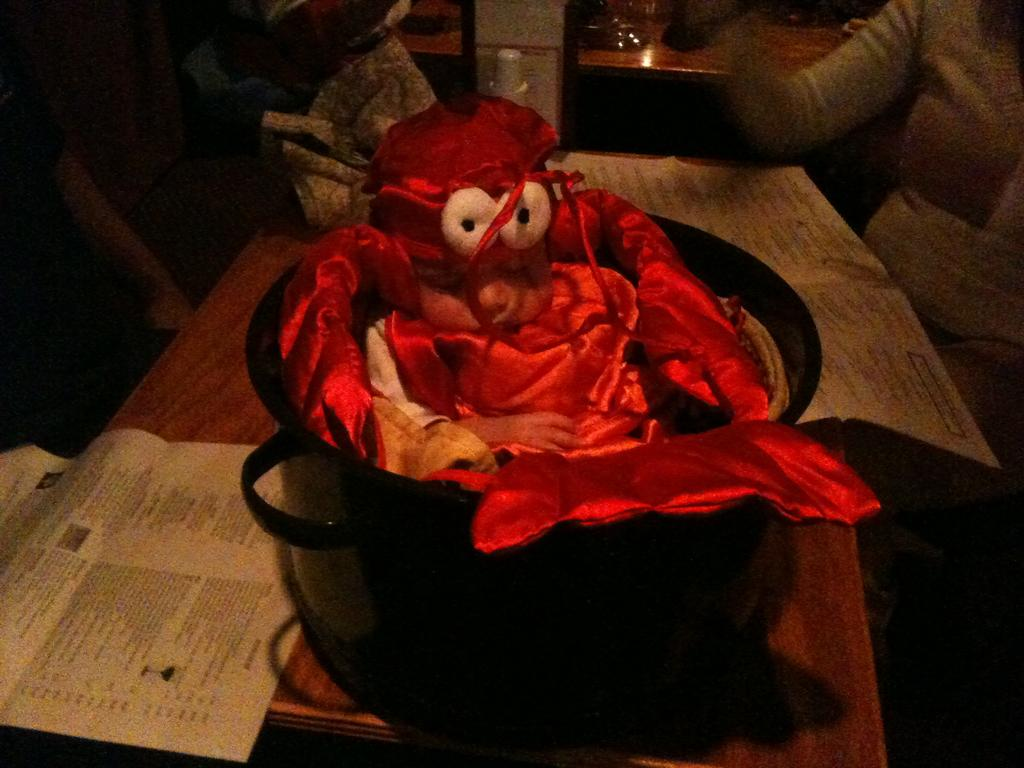What is placed in the bowl in the image? There is a toy in a bowl in the image. Where is the bowl located? The bowl is placed on a table. What else can be seen on the table? Papers and other objects are on the table. Who else is present in the image? There is another person in front of the table. What type of prose is being read by the toy in the image? There is no text or reading material present in the image, so it is not possible to determine if any prose is being read by the toy. 